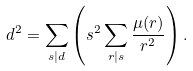Convert formula to latex. <formula><loc_0><loc_0><loc_500><loc_500>d ^ { 2 } = \sum _ { s | d } \left ( s ^ { 2 } \sum _ { r | s } \frac { \mu ( r ) } { r ^ { 2 } } \right ) .</formula> 